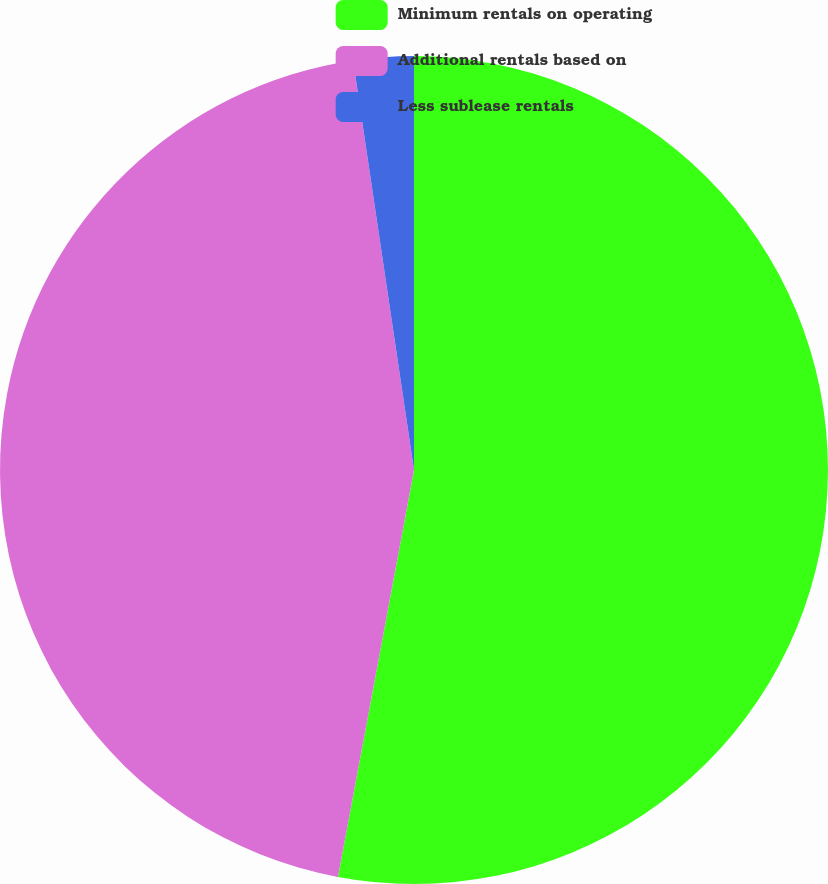Convert chart to OTSL. <chart><loc_0><loc_0><loc_500><loc_500><pie_chart><fcel>Minimum rentals on operating<fcel>Additional rentals based on<fcel>Less sublease rentals<nl><fcel>52.94%<fcel>44.71%<fcel>2.35%<nl></chart> 